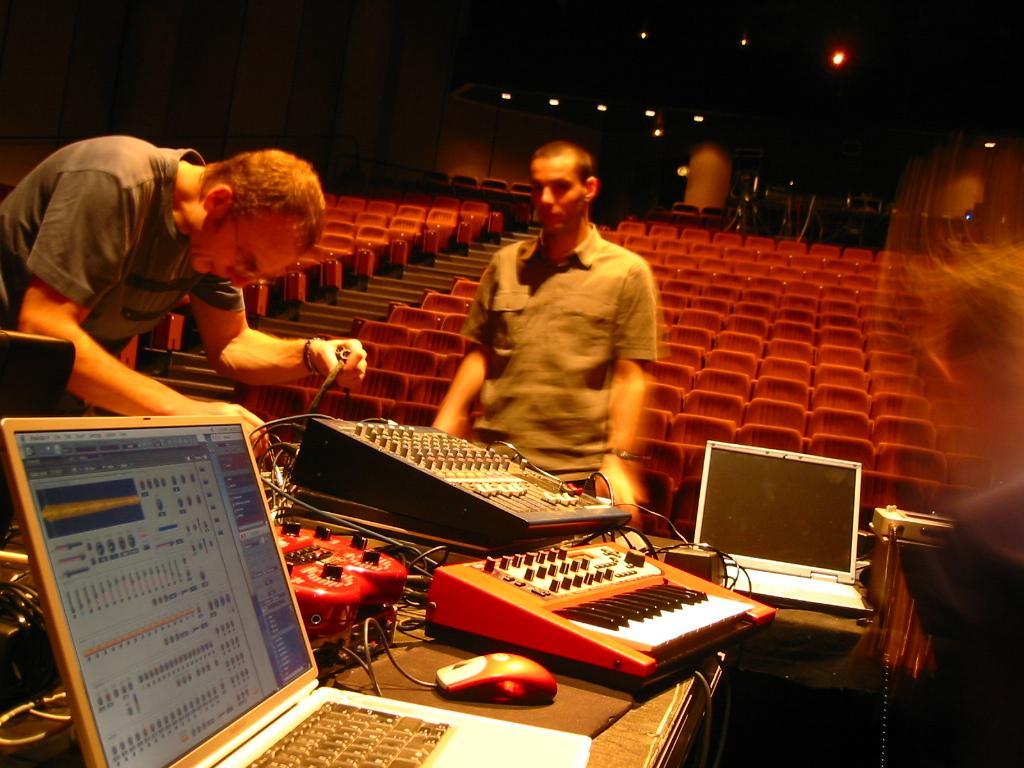How would you summarize this image in a sentence or two? In the middle of the image two persons are standing. Behind them there are some chairs. Bottom of the image there is a table, on the table there is a laptop and there are some musical instruments. 